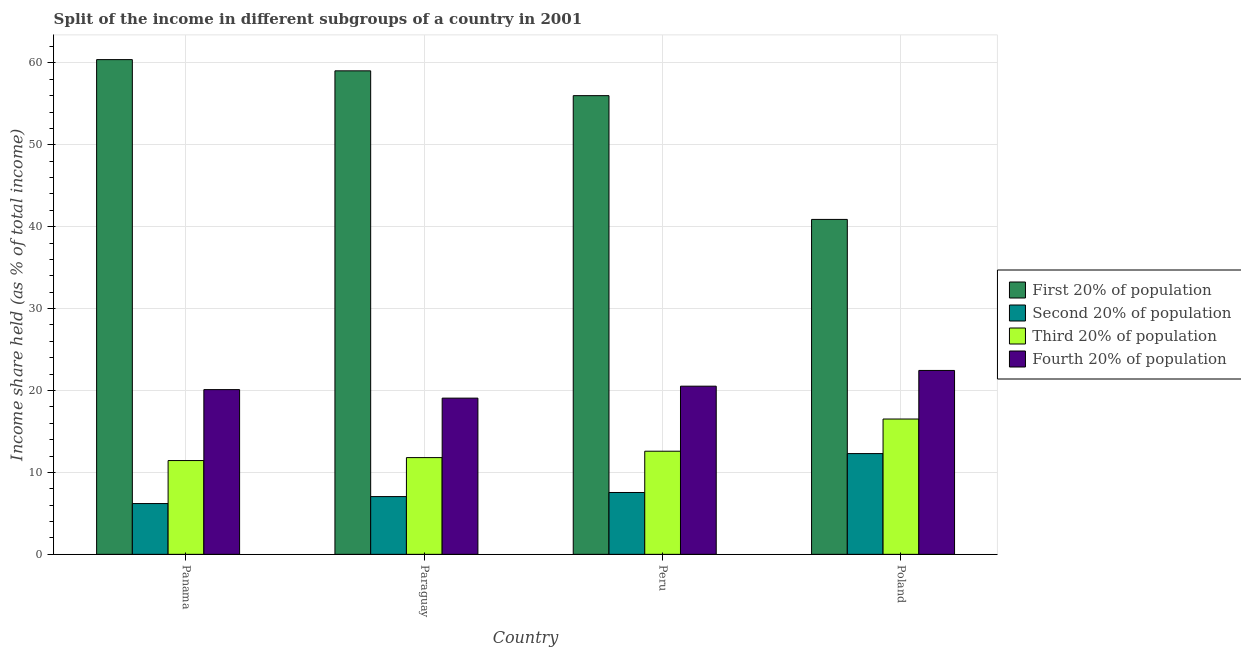How many groups of bars are there?
Provide a short and direct response. 4. Are the number of bars per tick equal to the number of legend labels?
Provide a short and direct response. Yes. Are the number of bars on each tick of the X-axis equal?
Your answer should be compact. Yes. How many bars are there on the 1st tick from the left?
Your response must be concise. 4. How many bars are there on the 3rd tick from the right?
Make the answer very short. 4. What is the label of the 2nd group of bars from the left?
Make the answer very short. Paraguay. In how many cases, is the number of bars for a given country not equal to the number of legend labels?
Provide a succinct answer. 0. Across all countries, what is the maximum share of the income held by second 20% of the population?
Offer a very short reply. 12.3. Across all countries, what is the minimum share of the income held by first 20% of the population?
Give a very brief answer. 40.89. In which country was the share of the income held by fourth 20% of the population maximum?
Your answer should be compact. Poland. In which country was the share of the income held by first 20% of the population minimum?
Offer a very short reply. Poland. What is the total share of the income held by third 20% of the population in the graph?
Keep it short and to the point. 52.37. What is the difference between the share of the income held by second 20% of the population in Paraguay and that in Poland?
Make the answer very short. -5.25. What is the difference between the share of the income held by fourth 20% of the population in Peru and the share of the income held by first 20% of the population in Panama?
Your response must be concise. -39.87. What is the average share of the income held by first 20% of the population per country?
Provide a short and direct response. 54.08. What is the difference between the share of the income held by second 20% of the population and share of the income held by first 20% of the population in Paraguay?
Your response must be concise. -51.98. In how many countries, is the share of the income held by fourth 20% of the population greater than 26 %?
Keep it short and to the point. 0. What is the ratio of the share of the income held by third 20% of the population in Paraguay to that in Poland?
Your answer should be compact. 0.71. Is the difference between the share of the income held by third 20% of the population in Paraguay and Peru greater than the difference between the share of the income held by second 20% of the population in Paraguay and Peru?
Provide a short and direct response. No. What is the difference between the highest and the second highest share of the income held by fourth 20% of the population?
Provide a succinct answer. 1.92. What is the difference between the highest and the lowest share of the income held by fourth 20% of the population?
Provide a short and direct response. 3.38. In how many countries, is the share of the income held by fourth 20% of the population greater than the average share of the income held by fourth 20% of the population taken over all countries?
Offer a very short reply. 1. Is it the case that in every country, the sum of the share of the income held by third 20% of the population and share of the income held by second 20% of the population is greater than the sum of share of the income held by first 20% of the population and share of the income held by fourth 20% of the population?
Your response must be concise. Yes. What does the 3rd bar from the left in Peru represents?
Your answer should be compact. Third 20% of population. What does the 1st bar from the right in Poland represents?
Ensure brevity in your answer.  Fourth 20% of population. Is it the case that in every country, the sum of the share of the income held by first 20% of the population and share of the income held by second 20% of the population is greater than the share of the income held by third 20% of the population?
Give a very brief answer. Yes. How many bars are there?
Provide a short and direct response. 16. How many countries are there in the graph?
Ensure brevity in your answer.  4. What is the difference between two consecutive major ticks on the Y-axis?
Offer a terse response. 10. Does the graph contain any zero values?
Offer a very short reply. No. Does the graph contain grids?
Ensure brevity in your answer.  Yes. Where does the legend appear in the graph?
Make the answer very short. Center right. How many legend labels are there?
Provide a short and direct response. 4. What is the title of the graph?
Offer a terse response. Split of the income in different subgroups of a country in 2001. Does "Water" appear as one of the legend labels in the graph?
Ensure brevity in your answer.  No. What is the label or title of the Y-axis?
Ensure brevity in your answer.  Income share held (as % of total income). What is the Income share held (as % of total income) in First 20% of population in Panama?
Your answer should be compact. 60.4. What is the Income share held (as % of total income) of Third 20% of population in Panama?
Offer a terse response. 11.45. What is the Income share held (as % of total income) in Fourth 20% of population in Panama?
Provide a short and direct response. 20.11. What is the Income share held (as % of total income) in First 20% of population in Paraguay?
Your response must be concise. 59.03. What is the Income share held (as % of total income) in Second 20% of population in Paraguay?
Provide a succinct answer. 7.05. What is the Income share held (as % of total income) of Third 20% of population in Paraguay?
Your response must be concise. 11.81. What is the Income share held (as % of total income) of Fourth 20% of population in Paraguay?
Provide a short and direct response. 19.07. What is the Income share held (as % of total income) in First 20% of population in Peru?
Your response must be concise. 56. What is the Income share held (as % of total income) of Second 20% of population in Peru?
Your answer should be compact. 7.55. What is the Income share held (as % of total income) of Third 20% of population in Peru?
Your response must be concise. 12.59. What is the Income share held (as % of total income) of Fourth 20% of population in Peru?
Offer a very short reply. 20.53. What is the Income share held (as % of total income) of First 20% of population in Poland?
Your answer should be compact. 40.89. What is the Income share held (as % of total income) in Third 20% of population in Poland?
Offer a terse response. 16.52. What is the Income share held (as % of total income) in Fourth 20% of population in Poland?
Ensure brevity in your answer.  22.45. Across all countries, what is the maximum Income share held (as % of total income) of First 20% of population?
Your answer should be compact. 60.4. Across all countries, what is the maximum Income share held (as % of total income) of Third 20% of population?
Ensure brevity in your answer.  16.52. Across all countries, what is the maximum Income share held (as % of total income) in Fourth 20% of population?
Keep it short and to the point. 22.45. Across all countries, what is the minimum Income share held (as % of total income) in First 20% of population?
Your answer should be very brief. 40.89. Across all countries, what is the minimum Income share held (as % of total income) of Third 20% of population?
Provide a short and direct response. 11.45. Across all countries, what is the minimum Income share held (as % of total income) of Fourth 20% of population?
Your answer should be compact. 19.07. What is the total Income share held (as % of total income) of First 20% of population in the graph?
Give a very brief answer. 216.32. What is the total Income share held (as % of total income) of Second 20% of population in the graph?
Make the answer very short. 33.1. What is the total Income share held (as % of total income) in Third 20% of population in the graph?
Your answer should be compact. 52.37. What is the total Income share held (as % of total income) of Fourth 20% of population in the graph?
Provide a short and direct response. 82.16. What is the difference between the Income share held (as % of total income) in First 20% of population in Panama and that in Paraguay?
Make the answer very short. 1.37. What is the difference between the Income share held (as % of total income) in Second 20% of population in Panama and that in Paraguay?
Your response must be concise. -0.85. What is the difference between the Income share held (as % of total income) of Third 20% of population in Panama and that in Paraguay?
Provide a short and direct response. -0.36. What is the difference between the Income share held (as % of total income) of Fourth 20% of population in Panama and that in Paraguay?
Make the answer very short. 1.04. What is the difference between the Income share held (as % of total income) in Second 20% of population in Panama and that in Peru?
Offer a terse response. -1.35. What is the difference between the Income share held (as % of total income) in Third 20% of population in Panama and that in Peru?
Offer a terse response. -1.14. What is the difference between the Income share held (as % of total income) of Fourth 20% of population in Panama and that in Peru?
Offer a very short reply. -0.42. What is the difference between the Income share held (as % of total income) of First 20% of population in Panama and that in Poland?
Ensure brevity in your answer.  19.51. What is the difference between the Income share held (as % of total income) of Second 20% of population in Panama and that in Poland?
Provide a short and direct response. -6.1. What is the difference between the Income share held (as % of total income) of Third 20% of population in Panama and that in Poland?
Your answer should be compact. -5.07. What is the difference between the Income share held (as % of total income) of Fourth 20% of population in Panama and that in Poland?
Offer a terse response. -2.34. What is the difference between the Income share held (as % of total income) in First 20% of population in Paraguay and that in Peru?
Provide a succinct answer. 3.03. What is the difference between the Income share held (as % of total income) of Second 20% of population in Paraguay and that in Peru?
Offer a terse response. -0.5. What is the difference between the Income share held (as % of total income) of Third 20% of population in Paraguay and that in Peru?
Your answer should be very brief. -0.78. What is the difference between the Income share held (as % of total income) of Fourth 20% of population in Paraguay and that in Peru?
Ensure brevity in your answer.  -1.46. What is the difference between the Income share held (as % of total income) in First 20% of population in Paraguay and that in Poland?
Offer a terse response. 18.14. What is the difference between the Income share held (as % of total income) in Second 20% of population in Paraguay and that in Poland?
Offer a terse response. -5.25. What is the difference between the Income share held (as % of total income) of Third 20% of population in Paraguay and that in Poland?
Your answer should be compact. -4.71. What is the difference between the Income share held (as % of total income) of Fourth 20% of population in Paraguay and that in Poland?
Keep it short and to the point. -3.38. What is the difference between the Income share held (as % of total income) of First 20% of population in Peru and that in Poland?
Make the answer very short. 15.11. What is the difference between the Income share held (as % of total income) in Second 20% of population in Peru and that in Poland?
Your response must be concise. -4.75. What is the difference between the Income share held (as % of total income) of Third 20% of population in Peru and that in Poland?
Provide a succinct answer. -3.93. What is the difference between the Income share held (as % of total income) in Fourth 20% of population in Peru and that in Poland?
Offer a very short reply. -1.92. What is the difference between the Income share held (as % of total income) of First 20% of population in Panama and the Income share held (as % of total income) of Second 20% of population in Paraguay?
Offer a very short reply. 53.35. What is the difference between the Income share held (as % of total income) of First 20% of population in Panama and the Income share held (as % of total income) of Third 20% of population in Paraguay?
Ensure brevity in your answer.  48.59. What is the difference between the Income share held (as % of total income) in First 20% of population in Panama and the Income share held (as % of total income) in Fourth 20% of population in Paraguay?
Provide a succinct answer. 41.33. What is the difference between the Income share held (as % of total income) of Second 20% of population in Panama and the Income share held (as % of total income) of Third 20% of population in Paraguay?
Provide a succinct answer. -5.61. What is the difference between the Income share held (as % of total income) of Second 20% of population in Panama and the Income share held (as % of total income) of Fourth 20% of population in Paraguay?
Provide a succinct answer. -12.87. What is the difference between the Income share held (as % of total income) of Third 20% of population in Panama and the Income share held (as % of total income) of Fourth 20% of population in Paraguay?
Your answer should be very brief. -7.62. What is the difference between the Income share held (as % of total income) of First 20% of population in Panama and the Income share held (as % of total income) of Second 20% of population in Peru?
Your response must be concise. 52.85. What is the difference between the Income share held (as % of total income) in First 20% of population in Panama and the Income share held (as % of total income) in Third 20% of population in Peru?
Make the answer very short. 47.81. What is the difference between the Income share held (as % of total income) of First 20% of population in Panama and the Income share held (as % of total income) of Fourth 20% of population in Peru?
Your answer should be compact. 39.87. What is the difference between the Income share held (as % of total income) of Second 20% of population in Panama and the Income share held (as % of total income) of Third 20% of population in Peru?
Your answer should be very brief. -6.39. What is the difference between the Income share held (as % of total income) in Second 20% of population in Panama and the Income share held (as % of total income) in Fourth 20% of population in Peru?
Offer a very short reply. -14.33. What is the difference between the Income share held (as % of total income) in Third 20% of population in Panama and the Income share held (as % of total income) in Fourth 20% of population in Peru?
Ensure brevity in your answer.  -9.08. What is the difference between the Income share held (as % of total income) in First 20% of population in Panama and the Income share held (as % of total income) in Second 20% of population in Poland?
Your answer should be very brief. 48.1. What is the difference between the Income share held (as % of total income) in First 20% of population in Panama and the Income share held (as % of total income) in Third 20% of population in Poland?
Keep it short and to the point. 43.88. What is the difference between the Income share held (as % of total income) in First 20% of population in Panama and the Income share held (as % of total income) in Fourth 20% of population in Poland?
Your response must be concise. 37.95. What is the difference between the Income share held (as % of total income) in Second 20% of population in Panama and the Income share held (as % of total income) in Third 20% of population in Poland?
Your answer should be compact. -10.32. What is the difference between the Income share held (as % of total income) in Second 20% of population in Panama and the Income share held (as % of total income) in Fourth 20% of population in Poland?
Offer a very short reply. -16.25. What is the difference between the Income share held (as % of total income) of Third 20% of population in Panama and the Income share held (as % of total income) of Fourth 20% of population in Poland?
Ensure brevity in your answer.  -11. What is the difference between the Income share held (as % of total income) of First 20% of population in Paraguay and the Income share held (as % of total income) of Second 20% of population in Peru?
Your answer should be very brief. 51.48. What is the difference between the Income share held (as % of total income) of First 20% of population in Paraguay and the Income share held (as % of total income) of Third 20% of population in Peru?
Make the answer very short. 46.44. What is the difference between the Income share held (as % of total income) of First 20% of population in Paraguay and the Income share held (as % of total income) of Fourth 20% of population in Peru?
Provide a succinct answer. 38.5. What is the difference between the Income share held (as % of total income) of Second 20% of population in Paraguay and the Income share held (as % of total income) of Third 20% of population in Peru?
Provide a succinct answer. -5.54. What is the difference between the Income share held (as % of total income) in Second 20% of population in Paraguay and the Income share held (as % of total income) in Fourth 20% of population in Peru?
Provide a succinct answer. -13.48. What is the difference between the Income share held (as % of total income) of Third 20% of population in Paraguay and the Income share held (as % of total income) of Fourth 20% of population in Peru?
Your answer should be compact. -8.72. What is the difference between the Income share held (as % of total income) of First 20% of population in Paraguay and the Income share held (as % of total income) of Second 20% of population in Poland?
Offer a very short reply. 46.73. What is the difference between the Income share held (as % of total income) of First 20% of population in Paraguay and the Income share held (as % of total income) of Third 20% of population in Poland?
Provide a short and direct response. 42.51. What is the difference between the Income share held (as % of total income) in First 20% of population in Paraguay and the Income share held (as % of total income) in Fourth 20% of population in Poland?
Offer a very short reply. 36.58. What is the difference between the Income share held (as % of total income) in Second 20% of population in Paraguay and the Income share held (as % of total income) in Third 20% of population in Poland?
Your answer should be compact. -9.47. What is the difference between the Income share held (as % of total income) in Second 20% of population in Paraguay and the Income share held (as % of total income) in Fourth 20% of population in Poland?
Your answer should be very brief. -15.4. What is the difference between the Income share held (as % of total income) in Third 20% of population in Paraguay and the Income share held (as % of total income) in Fourth 20% of population in Poland?
Ensure brevity in your answer.  -10.64. What is the difference between the Income share held (as % of total income) in First 20% of population in Peru and the Income share held (as % of total income) in Second 20% of population in Poland?
Offer a very short reply. 43.7. What is the difference between the Income share held (as % of total income) in First 20% of population in Peru and the Income share held (as % of total income) in Third 20% of population in Poland?
Your answer should be very brief. 39.48. What is the difference between the Income share held (as % of total income) of First 20% of population in Peru and the Income share held (as % of total income) of Fourth 20% of population in Poland?
Offer a very short reply. 33.55. What is the difference between the Income share held (as % of total income) in Second 20% of population in Peru and the Income share held (as % of total income) in Third 20% of population in Poland?
Your answer should be compact. -8.97. What is the difference between the Income share held (as % of total income) of Second 20% of population in Peru and the Income share held (as % of total income) of Fourth 20% of population in Poland?
Ensure brevity in your answer.  -14.9. What is the difference between the Income share held (as % of total income) in Third 20% of population in Peru and the Income share held (as % of total income) in Fourth 20% of population in Poland?
Offer a terse response. -9.86. What is the average Income share held (as % of total income) of First 20% of population per country?
Keep it short and to the point. 54.08. What is the average Income share held (as % of total income) of Second 20% of population per country?
Offer a very short reply. 8.28. What is the average Income share held (as % of total income) of Third 20% of population per country?
Provide a succinct answer. 13.09. What is the average Income share held (as % of total income) in Fourth 20% of population per country?
Keep it short and to the point. 20.54. What is the difference between the Income share held (as % of total income) of First 20% of population and Income share held (as % of total income) of Second 20% of population in Panama?
Give a very brief answer. 54.2. What is the difference between the Income share held (as % of total income) in First 20% of population and Income share held (as % of total income) in Third 20% of population in Panama?
Give a very brief answer. 48.95. What is the difference between the Income share held (as % of total income) of First 20% of population and Income share held (as % of total income) of Fourth 20% of population in Panama?
Make the answer very short. 40.29. What is the difference between the Income share held (as % of total income) of Second 20% of population and Income share held (as % of total income) of Third 20% of population in Panama?
Offer a terse response. -5.25. What is the difference between the Income share held (as % of total income) of Second 20% of population and Income share held (as % of total income) of Fourth 20% of population in Panama?
Your response must be concise. -13.91. What is the difference between the Income share held (as % of total income) in Third 20% of population and Income share held (as % of total income) in Fourth 20% of population in Panama?
Offer a terse response. -8.66. What is the difference between the Income share held (as % of total income) of First 20% of population and Income share held (as % of total income) of Second 20% of population in Paraguay?
Your answer should be compact. 51.98. What is the difference between the Income share held (as % of total income) in First 20% of population and Income share held (as % of total income) in Third 20% of population in Paraguay?
Your answer should be compact. 47.22. What is the difference between the Income share held (as % of total income) of First 20% of population and Income share held (as % of total income) of Fourth 20% of population in Paraguay?
Provide a short and direct response. 39.96. What is the difference between the Income share held (as % of total income) in Second 20% of population and Income share held (as % of total income) in Third 20% of population in Paraguay?
Provide a succinct answer. -4.76. What is the difference between the Income share held (as % of total income) in Second 20% of population and Income share held (as % of total income) in Fourth 20% of population in Paraguay?
Offer a terse response. -12.02. What is the difference between the Income share held (as % of total income) in Third 20% of population and Income share held (as % of total income) in Fourth 20% of population in Paraguay?
Make the answer very short. -7.26. What is the difference between the Income share held (as % of total income) of First 20% of population and Income share held (as % of total income) of Second 20% of population in Peru?
Provide a short and direct response. 48.45. What is the difference between the Income share held (as % of total income) of First 20% of population and Income share held (as % of total income) of Third 20% of population in Peru?
Ensure brevity in your answer.  43.41. What is the difference between the Income share held (as % of total income) of First 20% of population and Income share held (as % of total income) of Fourth 20% of population in Peru?
Your answer should be compact. 35.47. What is the difference between the Income share held (as % of total income) in Second 20% of population and Income share held (as % of total income) in Third 20% of population in Peru?
Your answer should be very brief. -5.04. What is the difference between the Income share held (as % of total income) in Second 20% of population and Income share held (as % of total income) in Fourth 20% of population in Peru?
Offer a very short reply. -12.98. What is the difference between the Income share held (as % of total income) in Third 20% of population and Income share held (as % of total income) in Fourth 20% of population in Peru?
Ensure brevity in your answer.  -7.94. What is the difference between the Income share held (as % of total income) in First 20% of population and Income share held (as % of total income) in Second 20% of population in Poland?
Make the answer very short. 28.59. What is the difference between the Income share held (as % of total income) of First 20% of population and Income share held (as % of total income) of Third 20% of population in Poland?
Your answer should be very brief. 24.37. What is the difference between the Income share held (as % of total income) of First 20% of population and Income share held (as % of total income) of Fourth 20% of population in Poland?
Keep it short and to the point. 18.44. What is the difference between the Income share held (as % of total income) of Second 20% of population and Income share held (as % of total income) of Third 20% of population in Poland?
Your answer should be compact. -4.22. What is the difference between the Income share held (as % of total income) of Second 20% of population and Income share held (as % of total income) of Fourth 20% of population in Poland?
Your answer should be compact. -10.15. What is the difference between the Income share held (as % of total income) in Third 20% of population and Income share held (as % of total income) in Fourth 20% of population in Poland?
Your response must be concise. -5.93. What is the ratio of the Income share held (as % of total income) in First 20% of population in Panama to that in Paraguay?
Your response must be concise. 1.02. What is the ratio of the Income share held (as % of total income) in Second 20% of population in Panama to that in Paraguay?
Provide a succinct answer. 0.88. What is the ratio of the Income share held (as % of total income) in Third 20% of population in Panama to that in Paraguay?
Offer a very short reply. 0.97. What is the ratio of the Income share held (as % of total income) in Fourth 20% of population in Panama to that in Paraguay?
Ensure brevity in your answer.  1.05. What is the ratio of the Income share held (as % of total income) of First 20% of population in Panama to that in Peru?
Your answer should be compact. 1.08. What is the ratio of the Income share held (as % of total income) in Second 20% of population in Panama to that in Peru?
Your answer should be compact. 0.82. What is the ratio of the Income share held (as % of total income) in Third 20% of population in Panama to that in Peru?
Ensure brevity in your answer.  0.91. What is the ratio of the Income share held (as % of total income) in Fourth 20% of population in Panama to that in Peru?
Your answer should be very brief. 0.98. What is the ratio of the Income share held (as % of total income) in First 20% of population in Panama to that in Poland?
Provide a succinct answer. 1.48. What is the ratio of the Income share held (as % of total income) of Second 20% of population in Panama to that in Poland?
Make the answer very short. 0.5. What is the ratio of the Income share held (as % of total income) in Third 20% of population in Panama to that in Poland?
Offer a very short reply. 0.69. What is the ratio of the Income share held (as % of total income) in Fourth 20% of population in Panama to that in Poland?
Make the answer very short. 0.9. What is the ratio of the Income share held (as % of total income) in First 20% of population in Paraguay to that in Peru?
Offer a very short reply. 1.05. What is the ratio of the Income share held (as % of total income) of Second 20% of population in Paraguay to that in Peru?
Keep it short and to the point. 0.93. What is the ratio of the Income share held (as % of total income) in Third 20% of population in Paraguay to that in Peru?
Provide a succinct answer. 0.94. What is the ratio of the Income share held (as % of total income) of Fourth 20% of population in Paraguay to that in Peru?
Keep it short and to the point. 0.93. What is the ratio of the Income share held (as % of total income) in First 20% of population in Paraguay to that in Poland?
Offer a very short reply. 1.44. What is the ratio of the Income share held (as % of total income) of Second 20% of population in Paraguay to that in Poland?
Make the answer very short. 0.57. What is the ratio of the Income share held (as % of total income) of Third 20% of population in Paraguay to that in Poland?
Offer a terse response. 0.71. What is the ratio of the Income share held (as % of total income) in Fourth 20% of population in Paraguay to that in Poland?
Ensure brevity in your answer.  0.85. What is the ratio of the Income share held (as % of total income) of First 20% of population in Peru to that in Poland?
Offer a terse response. 1.37. What is the ratio of the Income share held (as % of total income) in Second 20% of population in Peru to that in Poland?
Provide a succinct answer. 0.61. What is the ratio of the Income share held (as % of total income) of Third 20% of population in Peru to that in Poland?
Keep it short and to the point. 0.76. What is the ratio of the Income share held (as % of total income) in Fourth 20% of population in Peru to that in Poland?
Offer a very short reply. 0.91. What is the difference between the highest and the second highest Income share held (as % of total income) in First 20% of population?
Provide a succinct answer. 1.37. What is the difference between the highest and the second highest Income share held (as % of total income) of Second 20% of population?
Offer a terse response. 4.75. What is the difference between the highest and the second highest Income share held (as % of total income) of Third 20% of population?
Your response must be concise. 3.93. What is the difference between the highest and the second highest Income share held (as % of total income) of Fourth 20% of population?
Provide a succinct answer. 1.92. What is the difference between the highest and the lowest Income share held (as % of total income) of First 20% of population?
Offer a terse response. 19.51. What is the difference between the highest and the lowest Income share held (as % of total income) in Third 20% of population?
Your response must be concise. 5.07. What is the difference between the highest and the lowest Income share held (as % of total income) of Fourth 20% of population?
Provide a short and direct response. 3.38. 